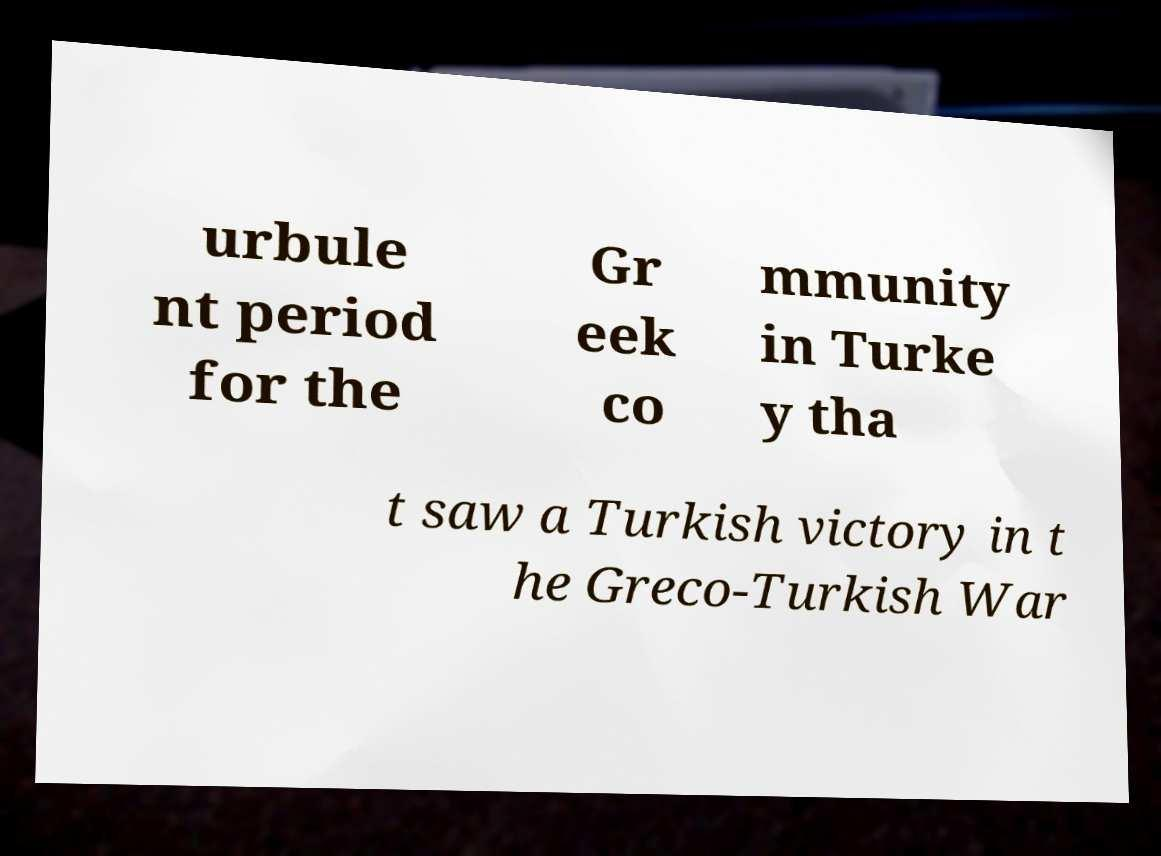Please identify and transcribe the text found in this image. urbule nt period for the Gr eek co mmunity in Turke y tha t saw a Turkish victory in t he Greco-Turkish War 